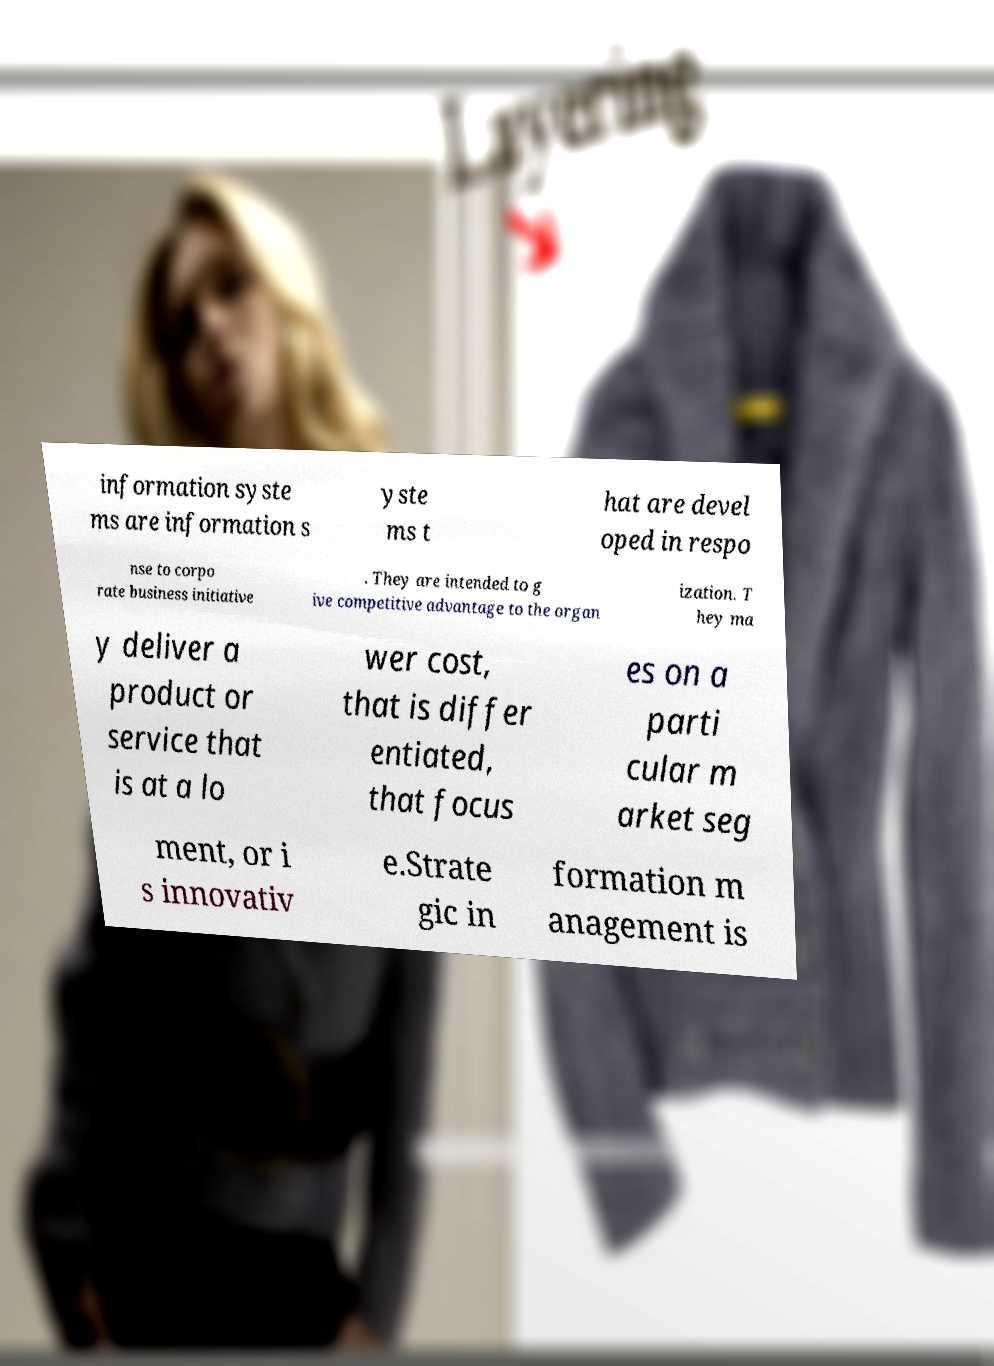What messages or text are displayed in this image? I need them in a readable, typed format. information syste ms are information s yste ms t hat are devel oped in respo nse to corpo rate business initiative . They are intended to g ive competitive advantage to the organ ization. T hey ma y deliver a product or service that is at a lo wer cost, that is differ entiated, that focus es on a parti cular m arket seg ment, or i s innovativ e.Strate gic in formation m anagement is 